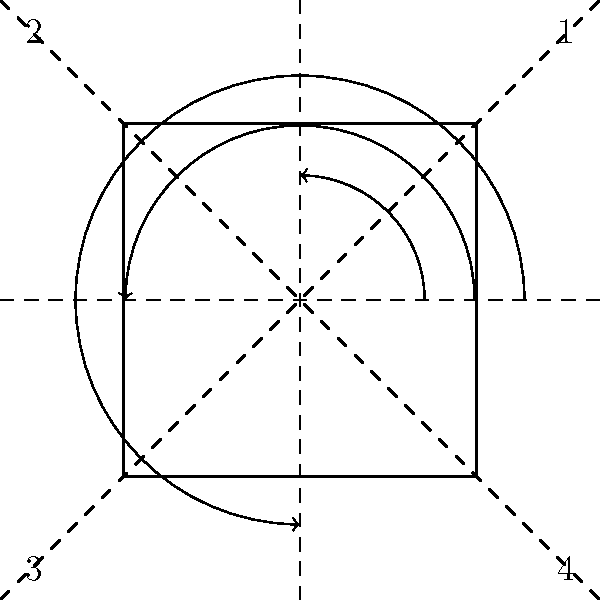In the dihedral group $D_4$, which is illustrated above using rotations and reflections of a square, how many unique elements (symmetries) are there in total? Explain your reasoning using the classical group theory approach. To determine the number of unique elements in the dihedral group $D_4$, we need to consider both rotations and reflections of the square:

1. Rotations:
   a) Identity (0° rotation)
   b) 90° clockwise rotation
   c) 180° rotation
   d) 270° clockwise rotation (or 90° counterclockwise)

   There are 4 distinct rotations.

2. Reflections:
   a) Reflection across the vertical axis
   b) Reflection across the horizontal axis
   c) Reflection across the diagonal from top-left to bottom-right
   d) Reflection across the diagonal from top-right to bottom-left

   There are 4 distinct reflections.

3. Group structure:
   The dihedral group $D_4$ is defined as the group of symmetries of a square. Each symmetry is either a rotation or a reflection.

4. Counting elements:
   Total number of elements = Number of rotations + Number of reflections
                            = 4 + 4 = 8

5. Verification:
   We can verify this result by considering that $D_4$ is generated by a rotation of order 4 and a reflection of order 2. The order of the group is then given by the product of these orders: 4 × 2 = 8.

Therefore, the dihedral group $D_4$ has 8 unique elements (symmetries).
Answer: 8 